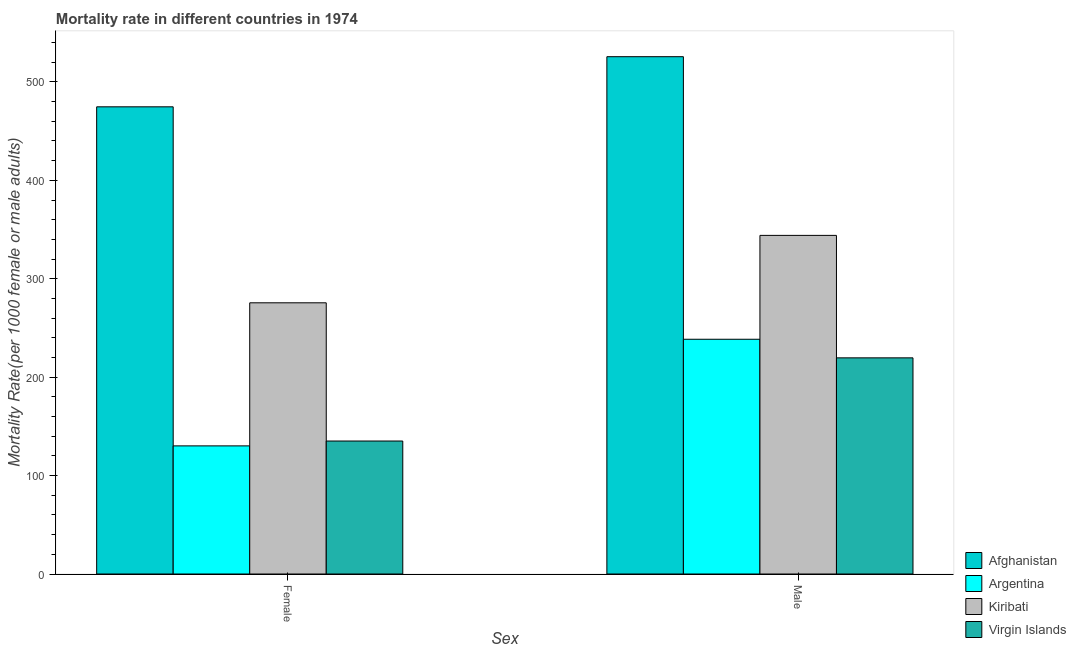How many different coloured bars are there?
Make the answer very short. 4. How many groups of bars are there?
Provide a succinct answer. 2. Are the number of bars per tick equal to the number of legend labels?
Provide a succinct answer. Yes. How many bars are there on the 1st tick from the left?
Your answer should be very brief. 4. What is the label of the 2nd group of bars from the left?
Your answer should be compact. Male. What is the male mortality rate in Virgin Islands?
Keep it short and to the point. 219.63. Across all countries, what is the maximum male mortality rate?
Your answer should be compact. 525.64. Across all countries, what is the minimum male mortality rate?
Your answer should be very brief. 219.63. In which country was the male mortality rate maximum?
Your answer should be very brief. Afghanistan. What is the total male mortality rate in the graph?
Give a very brief answer. 1327.86. What is the difference between the female mortality rate in Argentina and that in Kiribati?
Offer a terse response. -145.38. What is the difference between the female mortality rate in Afghanistan and the male mortality rate in Argentina?
Give a very brief answer. 236.19. What is the average female mortality rate per country?
Make the answer very short. 253.9. What is the difference between the male mortality rate and female mortality rate in Virgin Islands?
Offer a very short reply. 84.5. In how many countries, is the female mortality rate greater than 420 ?
Keep it short and to the point. 1. What is the ratio of the female mortality rate in Virgin Islands to that in Afghanistan?
Your answer should be compact. 0.28. In how many countries, is the female mortality rate greater than the average female mortality rate taken over all countries?
Offer a very short reply. 2. What does the 4th bar from the left in Male represents?
Provide a succinct answer. Virgin Islands. What does the 1st bar from the right in Female represents?
Your response must be concise. Virgin Islands. What is the difference between two consecutive major ticks on the Y-axis?
Offer a terse response. 100. Does the graph contain any zero values?
Provide a short and direct response. No. What is the title of the graph?
Offer a very short reply. Mortality rate in different countries in 1974. Does "China" appear as one of the legend labels in the graph?
Give a very brief answer. No. What is the label or title of the X-axis?
Your response must be concise. Sex. What is the label or title of the Y-axis?
Your response must be concise. Mortality Rate(per 1000 female or male adults). What is the Mortality Rate(per 1000 female or male adults) in Afghanistan in Female?
Offer a very short reply. 474.71. What is the Mortality Rate(per 1000 female or male adults) of Argentina in Female?
Offer a terse response. 130.19. What is the Mortality Rate(per 1000 female or male adults) of Kiribati in Female?
Ensure brevity in your answer.  275.56. What is the Mortality Rate(per 1000 female or male adults) in Virgin Islands in Female?
Offer a very short reply. 135.13. What is the Mortality Rate(per 1000 female or male adults) in Afghanistan in Male?
Provide a short and direct response. 525.64. What is the Mortality Rate(per 1000 female or male adults) of Argentina in Male?
Make the answer very short. 238.52. What is the Mortality Rate(per 1000 female or male adults) of Kiribati in Male?
Offer a very short reply. 344.07. What is the Mortality Rate(per 1000 female or male adults) of Virgin Islands in Male?
Your response must be concise. 219.63. Across all Sex, what is the maximum Mortality Rate(per 1000 female or male adults) in Afghanistan?
Make the answer very short. 525.64. Across all Sex, what is the maximum Mortality Rate(per 1000 female or male adults) in Argentina?
Offer a very short reply. 238.52. Across all Sex, what is the maximum Mortality Rate(per 1000 female or male adults) of Kiribati?
Ensure brevity in your answer.  344.07. Across all Sex, what is the maximum Mortality Rate(per 1000 female or male adults) of Virgin Islands?
Offer a very short reply. 219.63. Across all Sex, what is the minimum Mortality Rate(per 1000 female or male adults) in Afghanistan?
Provide a short and direct response. 474.71. Across all Sex, what is the minimum Mortality Rate(per 1000 female or male adults) of Argentina?
Keep it short and to the point. 130.19. Across all Sex, what is the minimum Mortality Rate(per 1000 female or male adults) of Kiribati?
Your answer should be very brief. 275.56. Across all Sex, what is the minimum Mortality Rate(per 1000 female or male adults) of Virgin Islands?
Your answer should be very brief. 135.13. What is the total Mortality Rate(per 1000 female or male adults) of Afghanistan in the graph?
Offer a very short reply. 1000.35. What is the total Mortality Rate(per 1000 female or male adults) of Argentina in the graph?
Your response must be concise. 368.71. What is the total Mortality Rate(per 1000 female or male adults) of Kiribati in the graph?
Make the answer very short. 619.63. What is the total Mortality Rate(per 1000 female or male adults) in Virgin Islands in the graph?
Provide a succinct answer. 354.75. What is the difference between the Mortality Rate(per 1000 female or male adults) of Afghanistan in Female and that in Male?
Make the answer very short. -50.93. What is the difference between the Mortality Rate(per 1000 female or male adults) in Argentina in Female and that in Male?
Your answer should be very brief. -108.34. What is the difference between the Mortality Rate(per 1000 female or male adults) of Kiribati in Female and that in Male?
Make the answer very short. -68.51. What is the difference between the Mortality Rate(per 1000 female or male adults) in Virgin Islands in Female and that in Male?
Provide a short and direct response. -84.5. What is the difference between the Mortality Rate(per 1000 female or male adults) in Afghanistan in Female and the Mortality Rate(per 1000 female or male adults) in Argentina in Male?
Your response must be concise. 236.19. What is the difference between the Mortality Rate(per 1000 female or male adults) of Afghanistan in Female and the Mortality Rate(per 1000 female or male adults) of Kiribati in Male?
Ensure brevity in your answer.  130.64. What is the difference between the Mortality Rate(per 1000 female or male adults) of Afghanistan in Female and the Mortality Rate(per 1000 female or male adults) of Virgin Islands in Male?
Provide a short and direct response. 255.08. What is the difference between the Mortality Rate(per 1000 female or male adults) in Argentina in Female and the Mortality Rate(per 1000 female or male adults) in Kiribati in Male?
Make the answer very short. -213.88. What is the difference between the Mortality Rate(per 1000 female or male adults) in Argentina in Female and the Mortality Rate(per 1000 female or male adults) in Virgin Islands in Male?
Keep it short and to the point. -89.44. What is the difference between the Mortality Rate(per 1000 female or male adults) of Kiribati in Female and the Mortality Rate(per 1000 female or male adults) of Virgin Islands in Male?
Provide a succinct answer. 55.94. What is the average Mortality Rate(per 1000 female or male adults) in Afghanistan per Sex?
Your response must be concise. 500.17. What is the average Mortality Rate(per 1000 female or male adults) of Argentina per Sex?
Offer a terse response. 184.35. What is the average Mortality Rate(per 1000 female or male adults) in Kiribati per Sex?
Your answer should be compact. 309.82. What is the average Mortality Rate(per 1000 female or male adults) in Virgin Islands per Sex?
Your answer should be very brief. 177.38. What is the difference between the Mortality Rate(per 1000 female or male adults) of Afghanistan and Mortality Rate(per 1000 female or male adults) of Argentina in Female?
Your response must be concise. 344.52. What is the difference between the Mortality Rate(per 1000 female or male adults) of Afghanistan and Mortality Rate(per 1000 female or male adults) of Kiribati in Female?
Keep it short and to the point. 199.15. What is the difference between the Mortality Rate(per 1000 female or male adults) in Afghanistan and Mortality Rate(per 1000 female or male adults) in Virgin Islands in Female?
Ensure brevity in your answer.  339.58. What is the difference between the Mortality Rate(per 1000 female or male adults) in Argentina and Mortality Rate(per 1000 female or male adults) in Kiribati in Female?
Your answer should be very brief. -145.38. What is the difference between the Mortality Rate(per 1000 female or male adults) in Argentina and Mortality Rate(per 1000 female or male adults) in Virgin Islands in Female?
Your answer should be very brief. -4.94. What is the difference between the Mortality Rate(per 1000 female or male adults) in Kiribati and Mortality Rate(per 1000 female or male adults) in Virgin Islands in Female?
Provide a short and direct response. 140.44. What is the difference between the Mortality Rate(per 1000 female or male adults) in Afghanistan and Mortality Rate(per 1000 female or male adults) in Argentina in Male?
Your answer should be very brief. 287.12. What is the difference between the Mortality Rate(per 1000 female or male adults) of Afghanistan and Mortality Rate(per 1000 female or male adults) of Kiribati in Male?
Ensure brevity in your answer.  181.57. What is the difference between the Mortality Rate(per 1000 female or male adults) of Afghanistan and Mortality Rate(per 1000 female or male adults) of Virgin Islands in Male?
Ensure brevity in your answer.  306.01. What is the difference between the Mortality Rate(per 1000 female or male adults) in Argentina and Mortality Rate(per 1000 female or male adults) in Kiribati in Male?
Offer a terse response. -105.55. What is the difference between the Mortality Rate(per 1000 female or male adults) in Argentina and Mortality Rate(per 1000 female or male adults) in Virgin Islands in Male?
Keep it short and to the point. 18.89. What is the difference between the Mortality Rate(per 1000 female or male adults) in Kiribati and Mortality Rate(per 1000 female or male adults) in Virgin Islands in Male?
Your answer should be very brief. 124.44. What is the ratio of the Mortality Rate(per 1000 female or male adults) in Afghanistan in Female to that in Male?
Make the answer very short. 0.9. What is the ratio of the Mortality Rate(per 1000 female or male adults) in Argentina in Female to that in Male?
Give a very brief answer. 0.55. What is the ratio of the Mortality Rate(per 1000 female or male adults) of Kiribati in Female to that in Male?
Make the answer very short. 0.8. What is the ratio of the Mortality Rate(per 1000 female or male adults) of Virgin Islands in Female to that in Male?
Your answer should be very brief. 0.62. What is the difference between the highest and the second highest Mortality Rate(per 1000 female or male adults) of Afghanistan?
Offer a very short reply. 50.93. What is the difference between the highest and the second highest Mortality Rate(per 1000 female or male adults) of Argentina?
Your answer should be very brief. 108.34. What is the difference between the highest and the second highest Mortality Rate(per 1000 female or male adults) in Kiribati?
Give a very brief answer. 68.51. What is the difference between the highest and the second highest Mortality Rate(per 1000 female or male adults) in Virgin Islands?
Your answer should be compact. 84.5. What is the difference between the highest and the lowest Mortality Rate(per 1000 female or male adults) of Afghanistan?
Your answer should be compact. 50.93. What is the difference between the highest and the lowest Mortality Rate(per 1000 female or male adults) of Argentina?
Make the answer very short. 108.34. What is the difference between the highest and the lowest Mortality Rate(per 1000 female or male adults) in Kiribati?
Offer a very short reply. 68.51. What is the difference between the highest and the lowest Mortality Rate(per 1000 female or male adults) of Virgin Islands?
Your response must be concise. 84.5. 